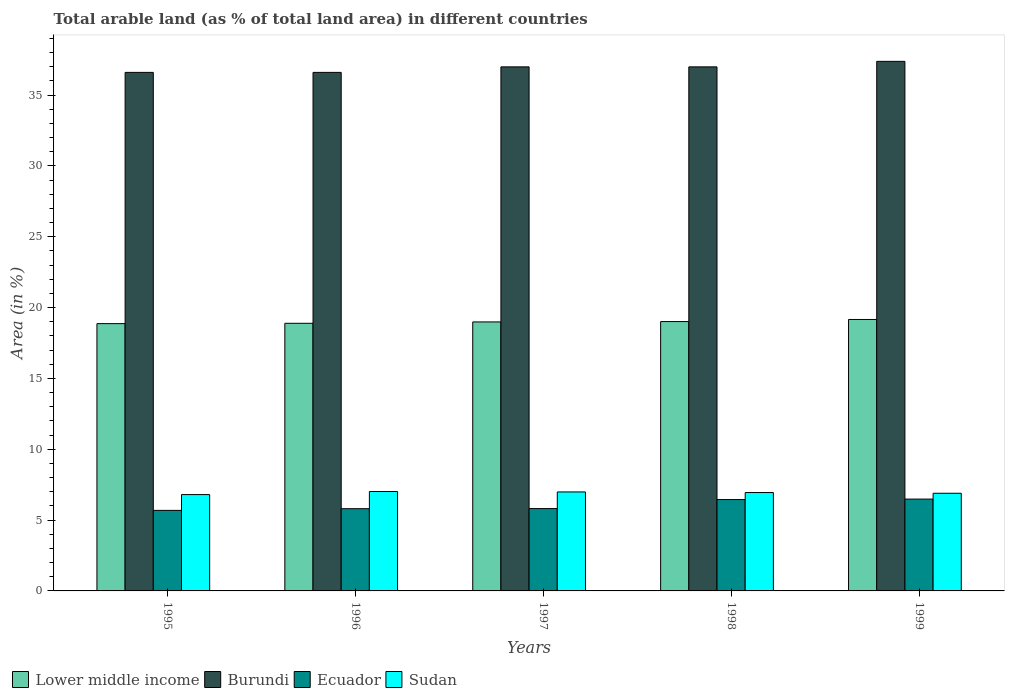Are the number of bars on each tick of the X-axis equal?
Provide a short and direct response. Yes. How many bars are there on the 5th tick from the left?
Keep it short and to the point. 4. How many bars are there on the 1st tick from the right?
Your answer should be compact. 4. In how many cases, is the number of bars for a given year not equal to the number of legend labels?
Offer a terse response. 0. What is the percentage of arable land in Ecuador in 1998?
Keep it short and to the point. 6.45. Across all years, what is the maximum percentage of arable land in Ecuador?
Ensure brevity in your answer.  6.48. Across all years, what is the minimum percentage of arable land in Sudan?
Make the answer very short. 6.8. What is the total percentage of arable land in Lower middle income in the graph?
Provide a succinct answer. 94.93. What is the difference between the percentage of arable land in Sudan in 1998 and that in 1999?
Ensure brevity in your answer.  0.05. What is the difference between the percentage of arable land in Lower middle income in 1997 and the percentage of arable land in Sudan in 1998?
Your response must be concise. 12.04. What is the average percentage of arable land in Ecuador per year?
Give a very brief answer. 6.05. In the year 1998, what is the difference between the percentage of arable land in Lower middle income and percentage of arable land in Burundi?
Your answer should be very brief. -17.98. What is the ratio of the percentage of arable land in Burundi in 1996 to that in 1999?
Your answer should be very brief. 0.98. Is the difference between the percentage of arable land in Lower middle income in 1996 and 1997 greater than the difference between the percentage of arable land in Burundi in 1996 and 1997?
Offer a very short reply. Yes. What is the difference between the highest and the second highest percentage of arable land in Ecuador?
Give a very brief answer. 0.03. What is the difference between the highest and the lowest percentage of arable land in Ecuador?
Provide a succinct answer. 0.8. In how many years, is the percentage of arable land in Sudan greater than the average percentage of arable land in Sudan taken over all years?
Your answer should be very brief. 3. Is it the case that in every year, the sum of the percentage of arable land in Ecuador and percentage of arable land in Sudan is greater than the sum of percentage of arable land in Lower middle income and percentage of arable land in Burundi?
Provide a succinct answer. No. What does the 3rd bar from the left in 1996 represents?
Your response must be concise. Ecuador. What does the 2nd bar from the right in 1997 represents?
Ensure brevity in your answer.  Ecuador. How many years are there in the graph?
Ensure brevity in your answer.  5. Are the values on the major ticks of Y-axis written in scientific E-notation?
Offer a very short reply. No. Does the graph contain grids?
Your response must be concise. No. Where does the legend appear in the graph?
Your answer should be compact. Bottom left. What is the title of the graph?
Your response must be concise. Total arable land (as % of total land area) in different countries. Does "Cyprus" appear as one of the legend labels in the graph?
Provide a short and direct response. No. What is the label or title of the X-axis?
Offer a very short reply. Years. What is the label or title of the Y-axis?
Offer a terse response. Area (in %). What is the Area (in %) of Lower middle income in 1995?
Your answer should be very brief. 18.87. What is the Area (in %) of Burundi in 1995?
Your answer should be very brief. 36.6. What is the Area (in %) of Ecuador in 1995?
Provide a short and direct response. 5.69. What is the Area (in %) in Sudan in 1995?
Your response must be concise. 6.8. What is the Area (in %) of Lower middle income in 1996?
Offer a very short reply. 18.89. What is the Area (in %) of Burundi in 1996?
Your answer should be compact. 36.6. What is the Area (in %) in Ecuador in 1996?
Make the answer very short. 5.8. What is the Area (in %) of Sudan in 1996?
Give a very brief answer. 7.02. What is the Area (in %) in Lower middle income in 1997?
Give a very brief answer. 18.99. What is the Area (in %) of Burundi in 1997?
Give a very brief answer. 36.99. What is the Area (in %) of Ecuador in 1997?
Ensure brevity in your answer.  5.81. What is the Area (in %) of Sudan in 1997?
Your response must be concise. 6.99. What is the Area (in %) of Lower middle income in 1998?
Provide a succinct answer. 19.01. What is the Area (in %) of Burundi in 1998?
Ensure brevity in your answer.  36.99. What is the Area (in %) in Ecuador in 1998?
Your answer should be very brief. 6.45. What is the Area (in %) of Sudan in 1998?
Ensure brevity in your answer.  6.94. What is the Area (in %) in Lower middle income in 1999?
Your answer should be compact. 19.16. What is the Area (in %) of Burundi in 1999?
Your answer should be very brief. 37.38. What is the Area (in %) of Ecuador in 1999?
Your answer should be compact. 6.48. What is the Area (in %) in Sudan in 1999?
Your response must be concise. 6.89. Across all years, what is the maximum Area (in %) of Lower middle income?
Provide a succinct answer. 19.16. Across all years, what is the maximum Area (in %) in Burundi?
Offer a terse response. 37.38. Across all years, what is the maximum Area (in %) in Ecuador?
Your answer should be very brief. 6.48. Across all years, what is the maximum Area (in %) of Sudan?
Offer a very short reply. 7.02. Across all years, what is the minimum Area (in %) in Lower middle income?
Give a very brief answer. 18.87. Across all years, what is the minimum Area (in %) of Burundi?
Ensure brevity in your answer.  36.6. Across all years, what is the minimum Area (in %) in Ecuador?
Make the answer very short. 5.69. Across all years, what is the minimum Area (in %) of Sudan?
Provide a short and direct response. 6.8. What is the total Area (in %) of Lower middle income in the graph?
Keep it short and to the point. 94.93. What is the total Area (in %) in Burundi in the graph?
Provide a short and direct response. 184.58. What is the total Area (in %) in Ecuador in the graph?
Give a very brief answer. 30.24. What is the total Area (in %) in Sudan in the graph?
Your answer should be compact. 34.64. What is the difference between the Area (in %) in Lower middle income in 1995 and that in 1996?
Provide a succinct answer. -0.02. What is the difference between the Area (in %) in Burundi in 1995 and that in 1996?
Your response must be concise. 0. What is the difference between the Area (in %) in Ecuador in 1995 and that in 1996?
Provide a short and direct response. -0.12. What is the difference between the Area (in %) of Sudan in 1995 and that in 1996?
Make the answer very short. -0.22. What is the difference between the Area (in %) of Lower middle income in 1995 and that in 1997?
Your answer should be very brief. -0.12. What is the difference between the Area (in %) of Burundi in 1995 and that in 1997?
Your answer should be compact. -0.39. What is the difference between the Area (in %) in Ecuador in 1995 and that in 1997?
Ensure brevity in your answer.  -0.13. What is the difference between the Area (in %) in Sudan in 1995 and that in 1997?
Keep it short and to the point. -0.19. What is the difference between the Area (in %) in Lower middle income in 1995 and that in 1998?
Offer a very short reply. -0.15. What is the difference between the Area (in %) of Burundi in 1995 and that in 1998?
Your response must be concise. -0.39. What is the difference between the Area (in %) in Ecuador in 1995 and that in 1998?
Offer a terse response. -0.76. What is the difference between the Area (in %) of Sudan in 1995 and that in 1998?
Your answer should be compact. -0.14. What is the difference between the Area (in %) in Lower middle income in 1995 and that in 1999?
Provide a succinct answer. -0.29. What is the difference between the Area (in %) of Burundi in 1995 and that in 1999?
Make the answer very short. -0.78. What is the difference between the Area (in %) of Ecuador in 1995 and that in 1999?
Your answer should be very brief. -0.8. What is the difference between the Area (in %) of Sudan in 1995 and that in 1999?
Ensure brevity in your answer.  -0.09. What is the difference between the Area (in %) of Lower middle income in 1996 and that in 1997?
Your answer should be compact. -0.1. What is the difference between the Area (in %) in Burundi in 1996 and that in 1997?
Offer a very short reply. -0.39. What is the difference between the Area (in %) in Ecuador in 1996 and that in 1997?
Your answer should be very brief. -0.01. What is the difference between the Area (in %) in Sudan in 1996 and that in 1997?
Provide a short and direct response. 0.03. What is the difference between the Area (in %) in Lower middle income in 1996 and that in 1998?
Ensure brevity in your answer.  -0.12. What is the difference between the Area (in %) of Burundi in 1996 and that in 1998?
Your answer should be compact. -0.39. What is the difference between the Area (in %) in Ecuador in 1996 and that in 1998?
Your answer should be very brief. -0.65. What is the difference between the Area (in %) in Sudan in 1996 and that in 1998?
Offer a very short reply. 0.07. What is the difference between the Area (in %) of Lower middle income in 1996 and that in 1999?
Provide a succinct answer. -0.27. What is the difference between the Area (in %) in Burundi in 1996 and that in 1999?
Make the answer very short. -0.78. What is the difference between the Area (in %) in Ecuador in 1996 and that in 1999?
Provide a succinct answer. -0.68. What is the difference between the Area (in %) of Sudan in 1996 and that in 1999?
Offer a terse response. 0.12. What is the difference between the Area (in %) of Lower middle income in 1997 and that in 1998?
Offer a terse response. -0.03. What is the difference between the Area (in %) of Ecuador in 1997 and that in 1998?
Your answer should be very brief. -0.64. What is the difference between the Area (in %) in Sudan in 1997 and that in 1998?
Offer a terse response. 0.04. What is the difference between the Area (in %) of Lower middle income in 1997 and that in 1999?
Offer a terse response. -0.17. What is the difference between the Area (in %) in Burundi in 1997 and that in 1999?
Provide a short and direct response. -0.39. What is the difference between the Area (in %) of Ecuador in 1997 and that in 1999?
Provide a short and direct response. -0.67. What is the difference between the Area (in %) in Sudan in 1997 and that in 1999?
Ensure brevity in your answer.  0.09. What is the difference between the Area (in %) of Lower middle income in 1998 and that in 1999?
Make the answer very short. -0.15. What is the difference between the Area (in %) in Burundi in 1998 and that in 1999?
Offer a terse response. -0.39. What is the difference between the Area (in %) in Ecuador in 1998 and that in 1999?
Offer a terse response. -0.03. What is the difference between the Area (in %) in Sudan in 1998 and that in 1999?
Your response must be concise. 0.05. What is the difference between the Area (in %) of Lower middle income in 1995 and the Area (in %) of Burundi in 1996?
Keep it short and to the point. -17.74. What is the difference between the Area (in %) in Lower middle income in 1995 and the Area (in %) in Ecuador in 1996?
Offer a very short reply. 13.06. What is the difference between the Area (in %) in Lower middle income in 1995 and the Area (in %) in Sudan in 1996?
Your answer should be very brief. 11.85. What is the difference between the Area (in %) in Burundi in 1995 and the Area (in %) in Ecuador in 1996?
Ensure brevity in your answer.  30.8. What is the difference between the Area (in %) in Burundi in 1995 and the Area (in %) in Sudan in 1996?
Offer a very short reply. 29.59. What is the difference between the Area (in %) in Ecuador in 1995 and the Area (in %) in Sudan in 1996?
Ensure brevity in your answer.  -1.33. What is the difference between the Area (in %) in Lower middle income in 1995 and the Area (in %) in Burundi in 1997?
Make the answer very short. -18.13. What is the difference between the Area (in %) in Lower middle income in 1995 and the Area (in %) in Ecuador in 1997?
Your response must be concise. 13.06. What is the difference between the Area (in %) of Lower middle income in 1995 and the Area (in %) of Sudan in 1997?
Ensure brevity in your answer.  11.88. What is the difference between the Area (in %) of Burundi in 1995 and the Area (in %) of Ecuador in 1997?
Your answer should be very brief. 30.79. What is the difference between the Area (in %) in Burundi in 1995 and the Area (in %) in Sudan in 1997?
Offer a very short reply. 29.62. What is the difference between the Area (in %) in Ecuador in 1995 and the Area (in %) in Sudan in 1997?
Your answer should be compact. -1.3. What is the difference between the Area (in %) of Lower middle income in 1995 and the Area (in %) of Burundi in 1998?
Offer a terse response. -18.13. What is the difference between the Area (in %) in Lower middle income in 1995 and the Area (in %) in Ecuador in 1998?
Provide a succinct answer. 12.42. What is the difference between the Area (in %) of Lower middle income in 1995 and the Area (in %) of Sudan in 1998?
Offer a terse response. 11.92. What is the difference between the Area (in %) of Burundi in 1995 and the Area (in %) of Ecuador in 1998?
Provide a short and direct response. 30.15. What is the difference between the Area (in %) in Burundi in 1995 and the Area (in %) in Sudan in 1998?
Give a very brief answer. 29.66. What is the difference between the Area (in %) in Ecuador in 1995 and the Area (in %) in Sudan in 1998?
Your response must be concise. -1.26. What is the difference between the Area (in %) of Lower middle income in 1995 and the Area (in %) of Burundi in 1999?
Offer a terse response. -18.51. What is the difference between the Area (in %) in Lower middle income in 1995 and the Area (in %) in Ecuador in 1999?
Offer a terse response. 12.39. What is the difference between the Area (in %) in Lower middle income in 1995 and the Area (in %) in Sudan in 1999?
Your answer should be compact. 11.97. What is the difference between the Area (in %) in Burundi in 1995 and the Area (in %) in Ecuador in 1999?
Offer a very short reply. 30.12. What is the difference between the Area (in %) of Burundi in 1995 and the Area (in %) of Sudan in 1999?
Provide a succinct answer. 29.71. What is the difference between the Area (in %) in Ecuador in 1995 and the Area (in %) in Sudan in 1999?
Ensure brevity in your answer.  -1.21. What is the difference between the Area (in %) of Lower middle income in 1996 and the Area (in %) of Burundi in 1997?
Give a very brief answer. -18.1. What is the difference between the Area (in %) of Lower middle income in 1996 and the Area (in %) of Ecuador in 1997?
Provide a succinct answer. 13.08. What is the difference between the Area (in %) of Lower middle income in 1996 and the Area (in %) of Sudan in 1997?
Keep it short and to the point. 11.91. What is the difference between the Area (in %) of Burundi in 1996 and the Area (in %) of Ecuador in 1997?
Offer a terse response. 30.79. What is the difference between the Area (in %) in Burundi in 1996 and the Area (in %) in Sudan in 1997?
Offer a terse response. 29.62. What is the difference between the Area (in %) of Ecuador in 1996 and the Area (in %) of Sudan in 1997?
Offer a very short reply. -1.18. What is the difference between the Area (in %) of Lower middle income in 1996 and the Area (in %) of Burundi in 1998?
Offer a terse response. -18.1. What is the difference between the Area (in %) of Lower middle income in 1996 and the Area (in %) of Ecuador in 1998?
Your response must be concise. 12.44. What is the difference between the Area (in %) in Lower middle income in 1996 and the Area (in %) in Sudan in 1998?
Your answer should be compact. 11.95. What is the difference between the Area (in %) in Burundi in 1996 and the Area (in %) in Ecuador in 1998?
Provide a succinct answer. 30.15. What is the difference between the Area (in %) of Burundi in 1996 and the Area (in %) of Sudan in 1998?
Your answer should be very brief. 29.66. What is the difference between the Area (in %) in Ecuador in 1996 and the Area (in %) in Sudan in 1998?
Keep it short and to the point. -1.14. What is the difference between the Area (in %) of Lower middle income in 1996 and the Area (in %) of Burundi in 1999?
Your answer should be very brief. -18.49. What is the difference between the Area (in %) of Lower middle income in 1996 and the Area (in %) of Ecuador in 1999?
Offer a very short reply. 12.41. What is the difference between the Area (in %) in Lower middle income in 1996 and the Area (in %) in Sudan in 1999?
Keep it short and to the point. 12. What is the difference between the Area (in %) in Burundi in 1996 and the Area (in %) in Ecuador in 1999?
Provide a succinct answer. 30.12. What is the difference between the Area (in %) in Burundi in 1996 and the Area (in %) in Sudan in 1999?
Provide a short and direct response. 29.71. What is the difference between the Area (in %) in Ecuador in 1996 and the Area (in %) in Sudan in 1999?
Give a very brief answer. -1.09. What is the difference between the Area (in %) in Lower middle income in 1997 and the Area (in %) in Burundi in 1998?
Ensure brevity in your answer.  -18. What is the difference between the Area (in %) in Lower middle income in 1997 and the Area (in %) in Ecuador in 1998?
Your answer should be compact. 12.54. What is the difference between the Area (in %) of Lower middle income in 1997 and the Area (in %) of Sudan in 1998?
Your answer should be very brief. 12.04. What is the difference between the Area (in %) in Burundi in 1997 and the Area (in %) in Ecuador in 1998?
Your answer should be compact. 30.54. What is the difference between the Area (in %) of Burundi in 1997 and the Area (in %) of Sudan in 1998?
Offer a terse response. 30.05. What is the difference between the Area (in %) of Ecuador in 1997 and the Area (in %) of Sudan in 1998?
Your response must be concise. -1.13. What is the difference between the Area (in %) in Lower middle income in 1997 and the Area (in %) in Burundi in 1999?
Offer a very short reply. -18.39. What is the difference between the Area (in %) in Lower middle income in 1997 and the Area (in %) in Ecuador in 1999?
Offer a very short reply. 12.51. What is the difference between the Area (in %) of Lower middle income in 1997 and the Area (in %) of Sudan in 1999?
Your response must be concise. 12.1. What is the difference between the Area (in %) in Burundi in 1997 and the Area (in %) in Ecuador in 1999?
Offer a very short reply. 30.51. What is the difference between the Area (in %) of Burundi in 1997 and the Area (in %) of Sudan in 1999?
Give a very brief answer. 30.1. What is the difference between the Area (in %) of Ecuador in 1997 and the Area (in %) of Sudan in 1999?
Make the answer very short. -1.08. What is the difference between the Area (in %) in Lower middle income in 1998 and the Area (in %) in Burundi in 1999?
Your answer should be very brief. -18.37. What is the difference between the Area (in %) of Lower middle income in 1998 and the Area (in %) of Ecuador in 1999?
Your response must be concise. 12.53. What is the difference between the Area (in %) in Lower middle income in 1998 and the Area (in %) in Sudan in 1999?
Give a very brief answer. 12.12. What is the difference between the Area (in %) of Burundi in 1998 and the Area (in %) of Ecuador in 1999?
Your response must be concise. 30.51. What is the difference between the Area (in %) in Burundi in 1998 and the Area (in %) in Sudan in 1999?
Keep it short and to the point. 30.1. What is the difference between the Area (in %) in Ecuador in 1998 and the Area (in %) in Sudan in 1999?
Make the answer very short. -0.44. What is the average Area (in %) of Lower middle income per year?
Your answer should be very brief. 18.99. What is the average Area (in %) of Burundi per year?
Offer a very short reply. 36.92. What is the average Area (in %) in Ecuador per year?
Ensure brevity in your answer.  6.05. What is the average Area (in %) of Sudan per year?
Give a very brief answer. 6.93. In the year 1995, what is the difference between the Area (in %) in Lower middle income and Area (in %) in Burundi?
Give a very brief answer. -17.74. In the year 1995, what is the difference between the Area (in %) in Lower middle income and Area (in %) in Ecuador?
Offer a very short reply. 13.18. In the year 1995, what is the difference between the Area (in %) of Lower middle income and Area (in %) of Sudan?
Your response must be concise. 12.07. In the year 1995, what is the difference between the Area (in %) of Burundi and Area (in %) of Ecuador?
Make the answer very short. 30.92. In the year 1995, what is the difference between the Area (in %) in Burundi and Area (in %) in Sudan?
Provide a short and direct response. 29.8. In the year 1995, what is the difference between the Area (in %) in Ecuador and Area (in %) in Sudan?
Offer a very short reply. -1.11. In the year 1996, what is the difference between the Area (in %) in Lower middle income and Area (in %) in Burundi?
Your answer should be very brief. -17.71. In the year 1996, what is the difference between the Area (in %) in Lower middle income and Area (in %) in Ecuador?
Ensure brevity in your answer.  13.09. In the year 1996, what is the difference between the Area (in %) in Lower middle income and Area (in %) in Sudan?
Offer a very short reply. 11.88. In the year 1996, what is the difference between the Area (in %) in Burundi and Area (in %) in Ecuador?
Your response must be concise. 30.8. In the year 1996, what is the difference between the Area (in %) in Burundi and Area (in %) in Sudan?
Keep it short and to the point. 29.59. In the year 1996, what is the difference between the Area (in %) of Ecuador and Area (in %) of Sudan?
Make the answer very short. -1.21. In the year 1997, what is the difference between the Area (in %) in Lower middle income and Area (in %) in Burundi?
Ensure brevity in your answer.  -18. In the year 1997, what is the difference between the Area (in %) of Lower middle income and Area (in %) of Ecuador?
Offer a very short reply. 13.18. In the year 1997, what is the difference between the Area (in %) of Lower middle income and Area (in %) of Sudan?
Keep it short and to the point. 12. In the year 1997, what is the difference between the Area (in %) of Burundi and Area (in %) of Ecuador?
Your response must be concise. 31.18. In the year 1997, what is the difference between the Area (in %) in Burundi and Area (in %) in Sudan?
Keep it short and to the point. 30.01. In the year 1997, what is the difference between the Area (in %) of Ecuador and Area (in %) of Sudan?
Provide a short and direct response. -1.17. In the year 1998, what is the difference between the Area (in %) in Lower middle income and Area (in %) in Burundi?
Offer a very short reply. -17.98. In the year 1998, what is the difference between the Area (in %) in Lower middle income and Area (in %) in Ecuador?
Give a very brief answer. 12.56. In the year 1998, what is the difference between the Area (in %) in Lower middle income and Area (in %) in Sudan?
Your answer should be compact. 12.07. In the year 1998, what is the difference between the Area (in %) in Burundi and Area (in %) in Ecuador?
Provide a succinct answer. 30.54. In the year 1998, what is the difference between the Area (in %) of Burundi and Area (in %) of Sudan?
Ensure brevity in your answer.  30.05. In the year 1998, what is the difference between the Area (in %) of Ecuador and Area (in %) of Sudan?
Your response must be concise. -0.49. In the year 1999, what is the difference between the Area (in %) of Lower middle income and Area (in %) of Burundi?
Make the answer very short. -18.22. In the year 1999, what is the difference between the Area (in %) in Lower middle income and Area (in %) in Ecuador?
Ensure brevity in your answer.  12.68. In the year 1999, what is the difference between the Area (in %) of Lower middle income and Area (in %) of Sudan?
Your response must be concise. 12.27. In the year 1999, what is the difference between the Area (in %) of Burundi and Area (in %) of Ecuador?
Your response must be concise. 30.9. In the year 1999, what is the difference between the Area (in %) of Burundi and Area (in %) of Sudan?
Keep it short and to the point. 30.49. In the year 1999, what is the difference between the Area (in %) of Ecuador and Area (in %) of Sudan?
Give a very brief answer. -0.41. What is the ratio of the Area (in %) in Lower middle income in 1995 to that in 1996?
Offer a terse response. 1. What is the ratio of the Area (in %) of Burundi in 1995 to that in 1996?
Give a very brief answer. 1. What is the ratio of the Area (in %) in Ecuador in 1995 to that in 1996?
Ensure brevity in your answer.  0.98. What is the ratio of the Area (in %) in Sudan in 1995 to that in 1996?
Keep it short and to the point. 0.97. What is the ratio of the Area (in %) in Lower middle income in 1995 to that in 1997?
Ensure brevity in your answer.  0.99. What is the ratio of the Area (in %) in Ecuador in 1995 to that in 1997?
Ensure brevity in your answer.  0.98. What is the ratio of the Area (in %) in Sudan in 1995 to that in 1997?
Make the answer very short. 0.97. What is the ratio of the Area (in %) of Ecuador in 1995 to that in 1998?
Keep it short and to the point. 0.88. What is the ratio of the Area (in %) in Sudan in 1995 to that in 1998?
Provide a succinct answer. 0.98. What is the ratio of the Area (in %) of Lower middle income in 1995 to that in 1999?
Offer a terse response. 0.98. What is the ratio of the Area (in %) in Burundi in 1995 to that in 1999?
Offer a terse response. 0.98. What is the ratio of the Area (in %) in Ecuador in 1995 to that in 1999?
Your answer should be compact. 0.88. What is the ratio of the Area (in %) of Sudan in 1995 to that in 1999?
Provide a succinct answer. 0.99. What is the ratio of the Area (in %) of Lower middle income in 1996 to that in 1997?
Provide a short and direct response. 0.99. What is the ratio of the Area (in %) in Sudan in 1996 to that in 1997?
Your answer should be compact. 1. What is the ratio of the Area (in %) of Lower middle income in 1996 to that in 1998?
Give a very brief answer. 0.99. What is the ratio of the Area (in %) of Burundi in 1996 to that in 1998?
Your answer should be compact. 0.99. What is the ratio of the Area (in %) of Ecuador in 1996 to that in 1998?
Offer a terse response. 0.9. What is the ratio of the Area (in %) of Sudan in 1996 to that in 1998?
Provide a succinct answer. 1.01. What is the ratio of the Area (in %) of Lower middle income in 1996 to that in 1999?
Ensure brevity in your answer.  0.99. What is the ratio of the Area (in %) in Burundi in 1996 to that in 1999?
Provide a succinct answer. 0.98. What is the ratio of the Area (in %) in Ecuador in 1996 to that in 1999?
Give a very brief answer. 0.9. What is the ratio of the Area (in %) of Sudan in 1996 to that in 1999?
Offer a very short reply. 1.02. What is the ratio of the Area (in %) in Lower middle income in 1997 to that in 1998?
Ensure brevity in your answer.  1. What is the ratio of the Area (in %) of Ecuador in 1997 to that in 1998?
Ensure brevity in your answer.  0.9. What is the ratio of the Area (in %) of Burundi in 1997 to that in 1999?
Offer a terse response. 0.99. What is the ratio of the Area (in %) of Ecuador in 1997 to that in 1999?
Your answer should be very brief. 0.9. What is the ratio of the Area (in %) in Sudan in 1997 to that in 1999?
Your response must be concise. 1.01. What is the ratio of the Area (in %) of Lower middle income in 1998 to that in 1999?
Give a very brief answer. 0.99. What is the ratio of the Area (in %) in Burundi in 1998 to that in 1999?
Your response must be concise. 0.99. What is the ratio of the Area (in %) in Ecuador in 1998 to that in 1999?
Your response must be concise. 0.99. What is the ratio of the Area (in %) of Sudan in 1998 to that in 1999?
Provide a short and direct response. 1.01. What is the difference between the highest and the second highest Area (in %) of Lower middle income?
Provide a short and direct response. 0.15. What is the difference between the highest and the second highest Area (in %) of Burundi?
Your answer should be very brief. 0.39. What is the difference between the highest and the second highest Area (in %) of Ecuador?
Your answer should be very brief. 0.03. What is the difference between the highest and the second highest Area (in %) of Sudan?
Your answer should be very brief. 0.03. What is the difference between the highest and the lowest Area (in %) of Lower middle income?
Make the answer very short. 0.29. What is the difference between the highest and the lowest Area (in %) in Burundi?
Your answer should be compact. 0.78. What is the difference between the highest and the lowest Area (in %) in Ecuador?
Provide a short and direct response. 0.8. What is the difference between the highest and the lowest Area (in %) of Sudan?
Your answer should be compact. 0.22. 